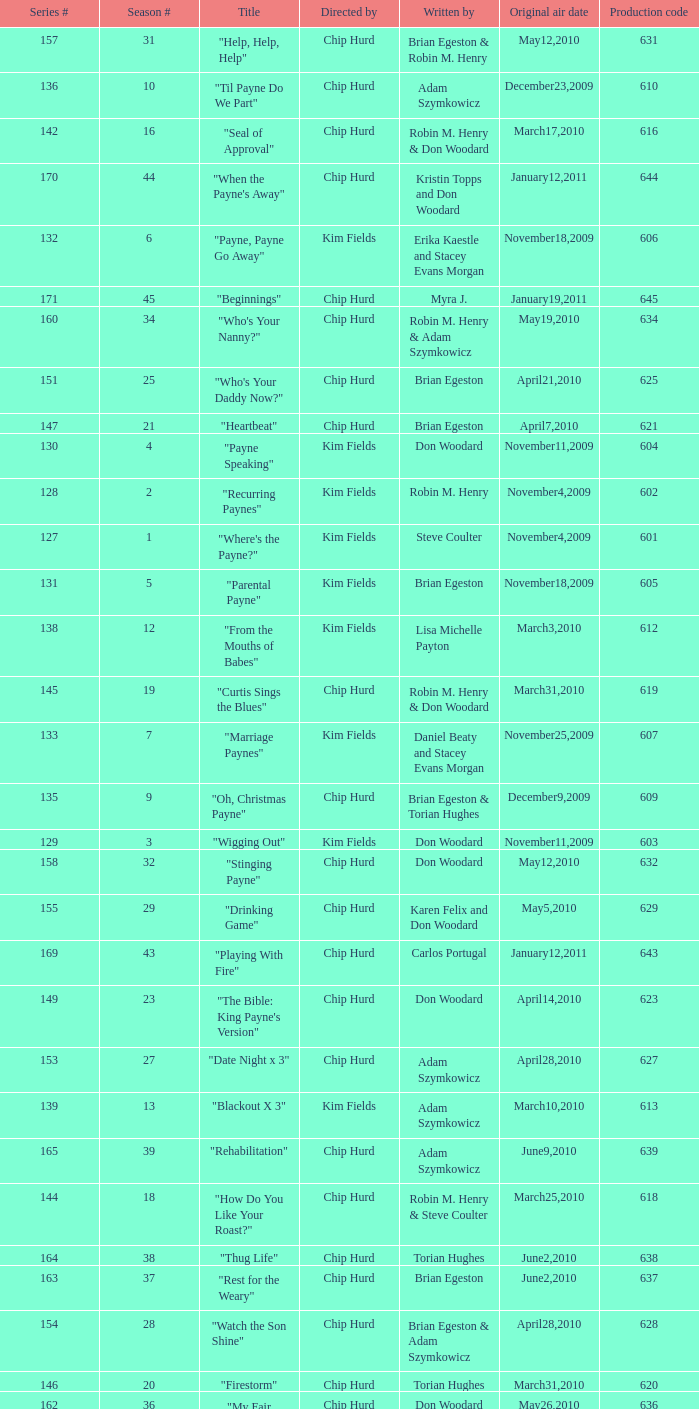What is the original air dates for the title "firestorm"? March31,2010. 